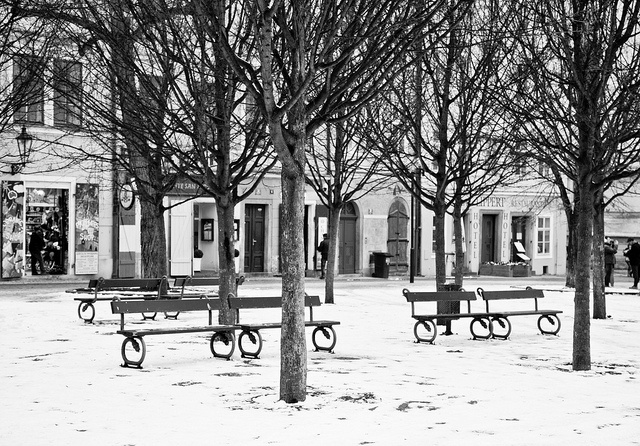Describe the objects in this image and their specific colors. I can see bench in black, white, gray, and darkgray tones, bench in black, white, gray, and darkgray tones, bench in black, white, gray, and darkgray tones, bench in black, white, gray, and darkgray tones, and bench in black, gray, darkgray, and white tones in this image. 